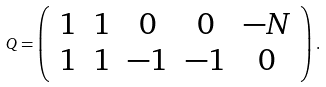Convert formula to latex. <formula><loc_0><loc_0><loc_500><loc_500>Q = \left ( \begin{array} { c c c c c } 1 & 1 & 0 & 0 & - N \\ 1 & 1 & - 1 & - 1 & 0 \end{array} \right ) .</formula> 